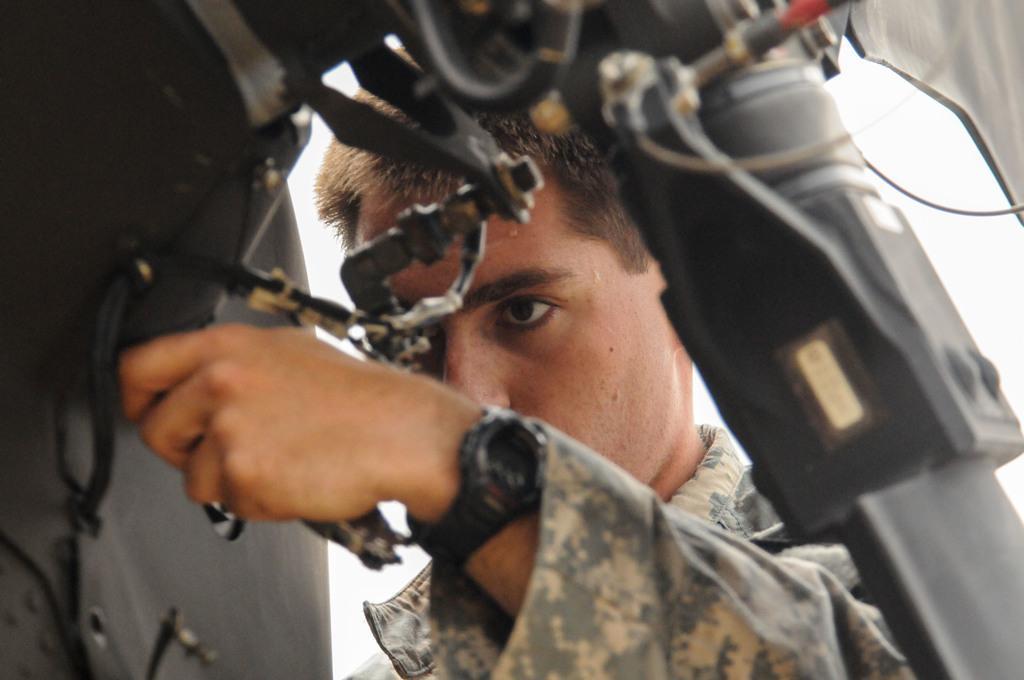Please provide a concise description of this image. In this image we can see a person holding an object. 